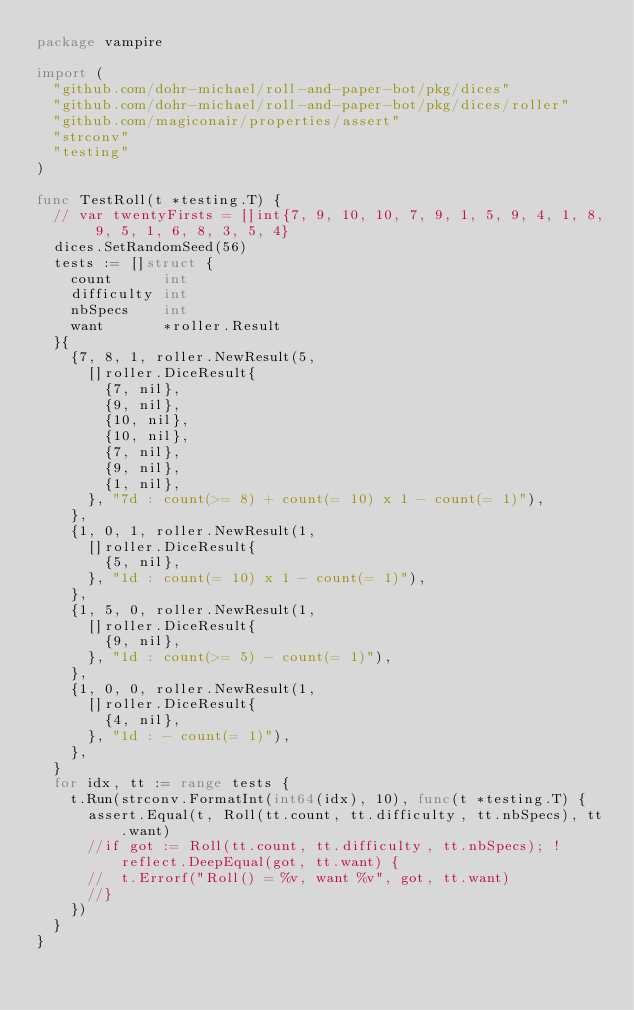Convert code to text. <code><loc_0><loc_0><loc_500><loc_500><_Go_>package vampire

import (
	"github.com/dohr-michael/roll-and-paper-bot/pkg/dices"
	"github.com/dohr-michael/roll-and-paper-bot/pkg/dices/roller"
	"github.com/magiconair/properties/assert"
	"strconv"
	"testing"
)

func TestRoll(t *testing.T) {
	// var twentyFirsts = []int{7, 9, 10, 10, 7, 9, 1, 5, 9, 4, 1, 8, 9, 5, 1, 6, 8, 3, 5, 4}
	dices.SetRandomSeed(56)
	tests := []struct {
		count      int
		difficulty int
		nbSpecs    int
		want       *roller.Result
	}{
		{7, 8, 1, roller.NewResult(5,
			[]roller.DiceResult{
				{7, nil},
				{9, nil},
				{10, nil},
				{10, nil},
				{7, nil},
				{9, nil},
				{1, nil},
			}, "7d : count(>= 8) + count(= 10) x 1 - count(= 1)"),
		},
		{1, 0, 1, roller.NewResult(1,
			[]roller.DiceResult{
				{5, nil},
			}, "1d : count(= 10) x 1 - count(= 1)"),
		},
		{1, 5, 0, roller.NewResult(1,
			[]roller.DiceResult{
				{9, nil},
			}, "1d : count(>= 5) - count(= 1)"),
		},
		{1, 0, 0, roller.NewResult(1,
			[]roller.DiceResult{
				{4, nil},
			}, "1d : - count(= 1)"),
		},
	}
	for idx, tt := range tests {
		t.Run(strconv.FormatInt(int64(idx), 10), func(t *testing.T) {
			assert.Equal(t, Roll(tt.count, tt.difficulty, tt.nbSpecs), tt.want)
			//if got := Roll(tt.count, tt.difficulty, tt.nbSpecs); !reflect.DeepEqual(got, tt.want) {
			//	t.Errorf("Roll() = %v, want %v", got, tt.want)
			//}
		})
	}
}
</code> 